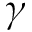<formula> <loc_0><loc_0><loc_500><loc_500>\gamma</formula> 